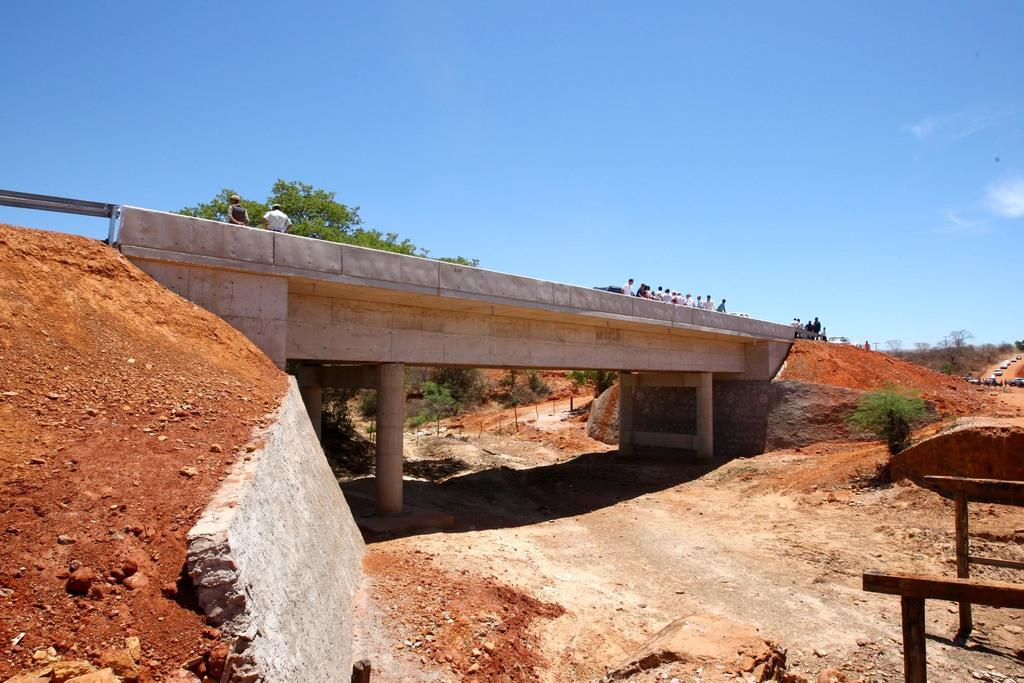What is the main subject in the foreground of the image? There is a bridge in the foreground of the image. What else can be seen in the foreground of the image? There is a group of people and fleets of cars on the road in the foreground of the image. What is visible in the background of the image? There are trees and the sky visible in the background of the image. What is the weather like in the image? The image was taken during a sunny day. What type of bread is being used to hold the screw in the image? There is no bread or screw present in the image. 